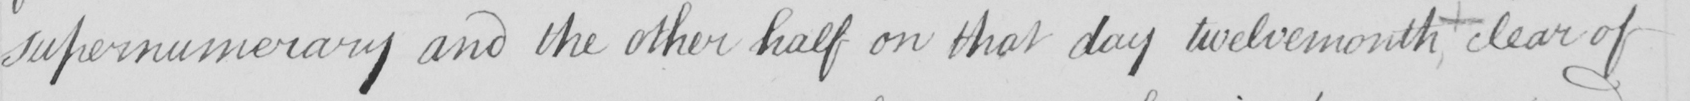Please provide the text content of this handwritten line. supernumerary and the other half on that day twelvemonth clear of 